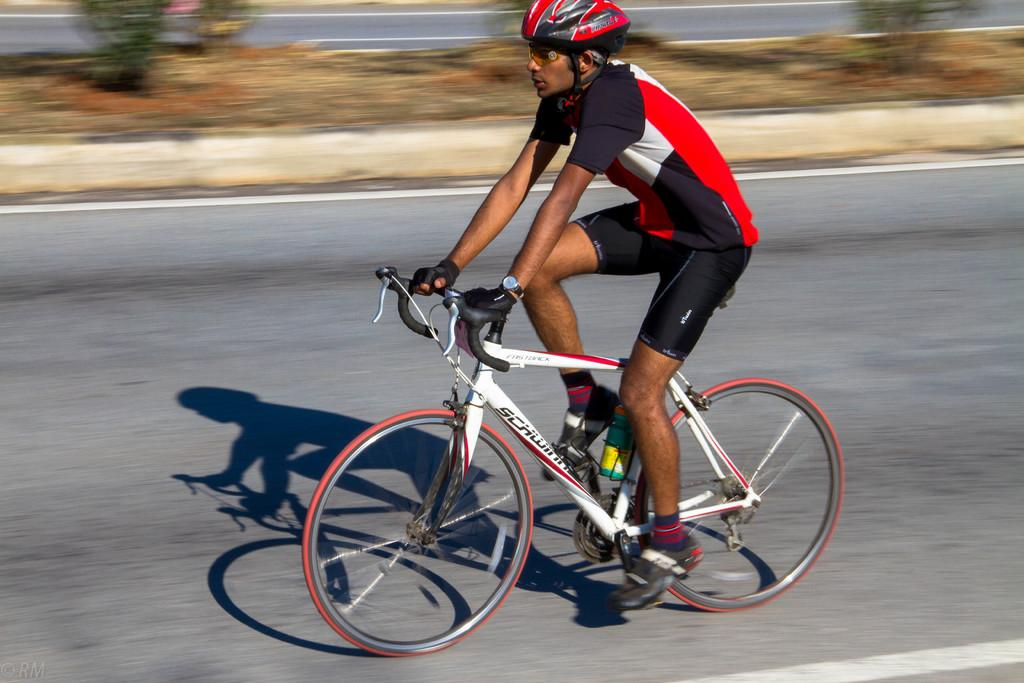Who is the main subject in the image? There is a man in the image. What is the man doing in the image? The man is driving a bicycle. Where is the bicycle located? The bicycle is on the road. What can be seen in the background of the image? There is a road and plants visible in the background of the image. What type of sound can be heard from the giraffe in the image? There is no giraffe present in the image, so no such sound can be heard. 